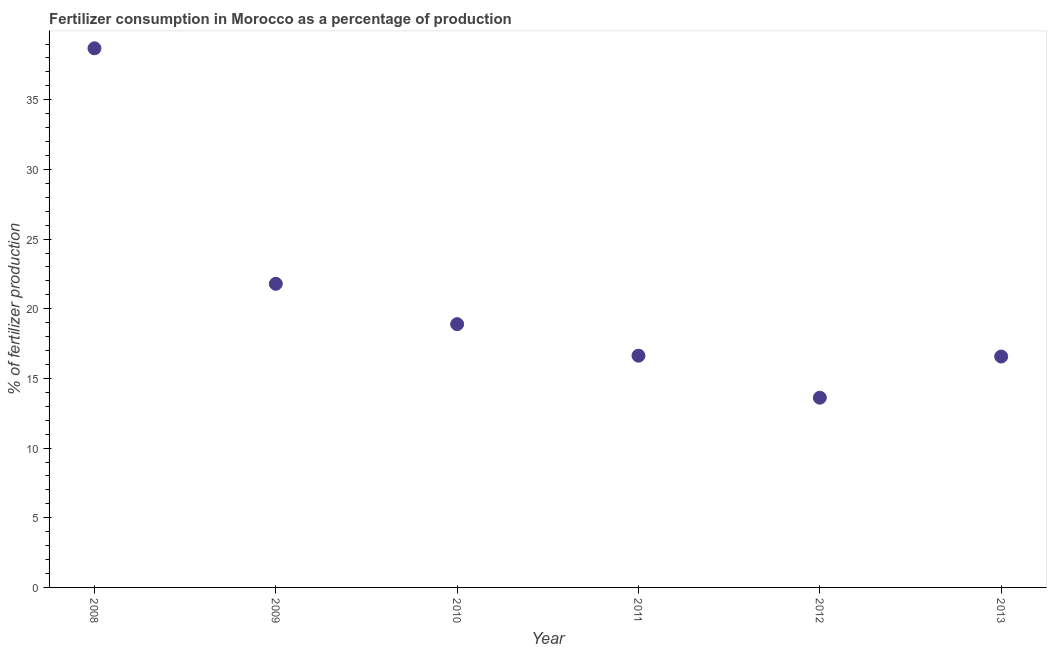What is the amount of fertilizer consumption in 2008?
Provide a succinct answer. 38.69. Across all years, what is the maximum amount of fertilizer consumption?
Provide a succinct answer. 38.69. Across all years, what is the minimum amount of fertilizer consumption?
Provide a short and direct response. 13.62. What is the sum of the amount of fertilizer consumption?
Your answer should be very brief. 126.2. What is the difference between the amount of fertilizer consumption in 2009 and 2013?
Your answer should be compact. 5.22. What is the average amount of fertilizer consumption per year?
Make the answer very short. 21.03. What is the median amount of fertilizer consumption?
Make the answer very short. 17.76. In how many years, is the amount of fertilizer consumption greater than 3 %?
Keep it short and to the point. 6. Do a majority of the years between 2013 and 2008 (inclusive) have amount of fertilizer consumption greater than 18 %?
Your answer should be compact. Yes. What is the ratio of the amount of fertilizer consumption in 2010 to that in 2012?
Make the answer very short. 1.39. Is the amount of fertilizer consumption in 2009 less than that in 2012?
Give a very brief answer. No. Is the difference between the amount of fertilizer consumption in 2012 and 2013 greater than the difference between any two years?
Offer a terse response. No. What is the difference between the highest and the second highest amount of fertilizer consumption?
Your answer should be compact. 16.9. What is the difference between the highest and the lowest amount of fertilizer consumption?
Provide a succinct answer. 25.08. What is the difference between two consecutive major ticks on the Y-axis?
Provide a short and direct response. 5. What is the title of the graph?
Offer a very short reply. Fertilizer consumption in Morocco as a percentage of production. What is the label or title of the X-axis?
Your answer should be very brief. Year. What is the label or title of the Y-axis?
Provide a succinct answer. % of fertilizer production. What is the % of fertilizer production in 2008?
Make the answer very short. 38.69. What is the % of fertilizer production in 2009?
Your response must be concise. 21.79. What is the % of fertilizer production in 2010?
Your response must be concise. 18.9. What is the % of fertilizer production in 2011?
Provide a short and direct response. 16.63. What is the % of fertilizer production in 2012?
Provide a succinct answer. 13.62. What is the % of fertilizer production in 2013?
Ensure brevity in your answer.  16.57. What is the difference between the % of fertilizer production in 2008 and 2009?
Give a very brief answer. 16.9. What is the difference between the % of fertilizer production in 2008 and 2010?
Keep it short and to the point. 19.8. What is the difference between the % of fertilizer production in 2008 and 2011?
Offer a very short reply. 22.06. What is the difference between the % of fertilizer production in 2008 and 2012?
Your response must be concise. 25.08. What is the difference between the % of fertilizer production in 2008 and 2013?
Provide a succinct answer. 22.12. What is the difference between the % of fertilizer production in 2009 and 2010?
Your response must be concise. 2.9. What is the difference between the % of fertilizer production in 2009 and 2011?
Provide a succinct answer. 5.16. What is the difference between the % of fertilizer production in 2009 and 2012?
Keep it short and to the point. 8.18. What is the difference between the % of fertilizer production in 2009 and 2013?
Provide a succinct answer. 5.22. What is the difference between the % of fertilizer production in 2010 and 2011?
Make the answer very short. 2.26. What is the difference between the % of fertilizer production in 2010 and 2012?
Keep it short and to the point. 5.28. What is the difference between the % of fertilizer production in 2010 and 2013?
Ensure brevity in your answer.  2.32. What is the difference between the % of fertilizer production in 2011 and 2012?
Ensure brevity in your answer.  3.01. What is the difference between the % of fertilizer production in 2011 and 2013?
Give a very brief answer. 0.06. What is the difference between the % of fertilizer production in 2012 and 2013?
Provide a short and direct response. -2.96. What is the ratio of the % of fertilizer production in 2008 to that in 2009?
Provide a short and direct response. 1.78. What is the ratio of the % of fertilizer production in 2008 to that in 2010?
Keep it short and to the point. 2.05. What is the ratio of the % of fertilizer production in 2008 to that in 2011?
Your answer should be compact. 2.33. What is the ratio of the % of fertilizer production in 2008 to that in 2012?
Your answer should be very brief. 2.84. What is the ratio of the % of fertilizer production in 2008 to that in 2013?
Your answer should be compact. 2.33. What is the ratio of the % of fertilizer production in 2009 to that in 2010?
Your answer should be compact. 1.15. What is the ratio of the % of fertilizer production in 2009 to that in 2011?
Give a very brief answer. 1.31. What is the ratio of the % of fertilizer production in 2009 to that in 2012?
Your response must be concise. 1.6. What is the ratio of the % of fertilizer production in 2009 to that in 2013?
Your answer should be very brief. 1.31. What is the ratio of the % of fertilizer production in 2010 to that in 2011?
Give a very brief answer. 1.14. What is the ratio of the % of fertilizer production in 2010 to that in 2012?
Your answer should be very brief. 1.39. What is the ratio of the % of fertilizer production in 2010 to that in 2013?
Keep it short and to the point. 1.14. What is the ratio of the % of fertilizer production in 2011 to that in 2012?
Give a very brief answer. 1.22. What is the ratio of the % of fertilizer production in 2012 to that in 2013?
Make the answer very short. 0.82. 